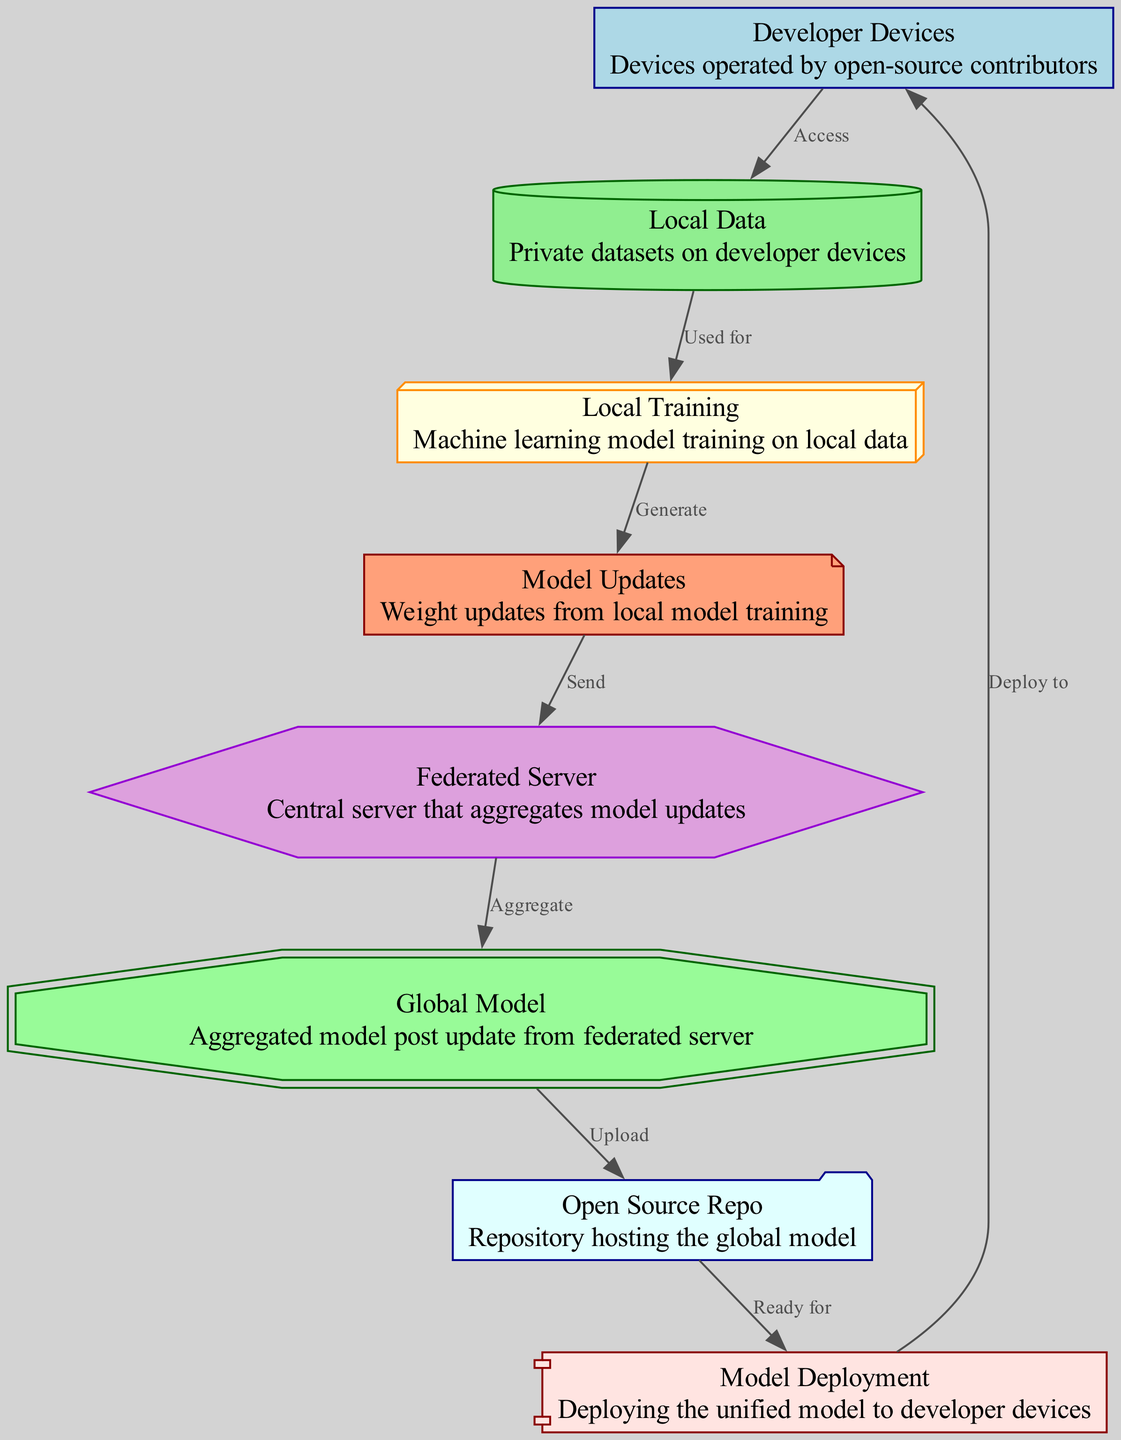What is the first step in federated learning architecture? The first step is represented by the "Developer Devices" node which indicates the starting point where devices operated by open-source contributors are involved.
Answer: Developer Devices How many nodes are in the diagram? By counting the nodes listed in the data, there are a total of eight nodes.
Answer: Eight What type of data is used for local training? The "Local Data" node specifies that the type of data involved in local training is private datasets on developer devices.
Answer: Private datasets What do "Model Updates" generate from local training? The "Model Updates" node indicates that they generate weight updates from local model training, showing the output of the training process.
Answer: Weight updates What action follows sending model updates to the federated server? After sending model updates to the federated server, the action is to "Aggregate" the updates into a global model.
Answer: Aggregate Where is the global model uploaded after aggregation? The global model is uploaded to the "Open Source Repo" node, which is the repository hosting the global model.
Answer: Open Source Repo What is the shape of the "Federated Server" node? The "Federated Server" node has a hexagon shape as indicated by the styling defined in the diagram data.
Answer: Hexagon Which node indicates readiness for model deployment? The node labeled "Open Source Repo" indicates that it is ready for model deployment, as shown by the flow from the global model node to this repository.
Answer: Open Source Repo What is the final step in the federated learning architecture? The final step is depicted by the "Model Deployment" node, which represents the deployment of the unified model to developer devices.
Answer: Model Deployment 